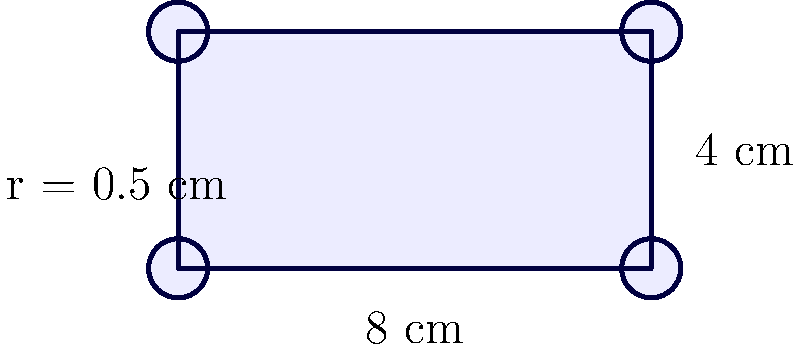You're designing a new fragrance strip for your blog to showcase a light, fresh scent. The strip is rectangular with rounded corners, as shown in the diagram. If the rectangular part measures 8 cm by 4 cm, and each rounded corner has a radius of 0.5 cm, what is the total area of the fragrance strip in square centimeters? To find the total area of the fragrance strip, we need to:

1. Calculate the area of the rectangular part:
   $A_{rectangle} = 8 \text{ cm} \times 4 \text{ cm} = 32 \text{ cm}^2$

2. Calculate the area of a full circle with radius 0.5 cm:
   $A_{circle} = \pi r^2 = \pi (0.5 \text{ cm})^2 = 0.25\pi \text{ cm}^2$

3. Calculate the area of one rounded corner (1/4 of a circle):
   $A_{corner} = \frac{1}{4} \times 0.25\pi \text{ cm}^2 = 0.0625\pi \text{ cm}^2$

4. Subtract the areas of the four corners from the rectangular area:
   $A_{total} = A_{rectangle} - 4 \times A_{corner}$
   $A_{total} = 32 \text{ cm}^2 - 4 \times 0.0625\pi \text{ cm}^2$
   $A_{total} = 32 \text{ cm}^2 - 0.25\pi \text{ cm}^2$

5. Simplify and calculate the final result:
   $A_{total} = 32 - 0.25\pi \text{ cm}^2$
   $A_{total} \approx 31.2146 \text{ cm}^2$
Answer: $31.21 \text{ cm}^2$ (rounded to 2 decimal places) 